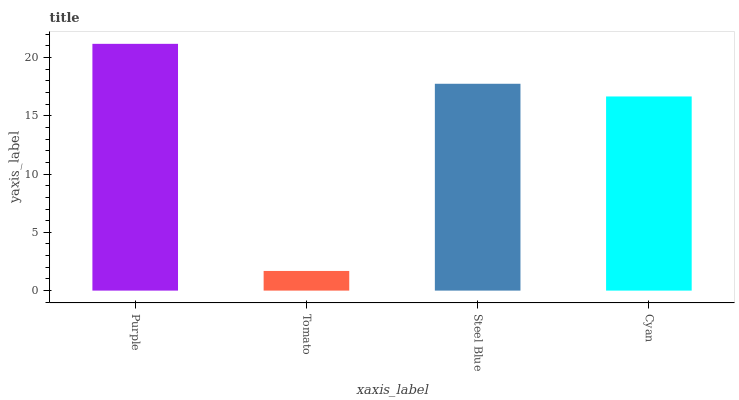Is Tomato the minimum?
Answer yes or no. Yes. Is Purple the maximum?
Answer yes or no. Yes. Is Steel Blue the minimum?
Answer yes or no. No. Is Steel Blue the maximum?
Answer yes or no. No. Is Steel Blue greater than Tomato?
Answer yes or no. Yes. Is Tomato less than Steel Blue?
Answer yes or no. Yes. Is Tomato greater than Steel Blue?
Answer yes or no. No. Is Steel Blue less than Tomato?
Answer yes or no. No. Is Steel Blue the high median?
Answer yes or no. Yes. Is Cyan the low median?
Answer yes or no. Yes. Is Cyan the high median?
Answer yes or no. No. Is Purple the low median?
Answer yes or no. No. 